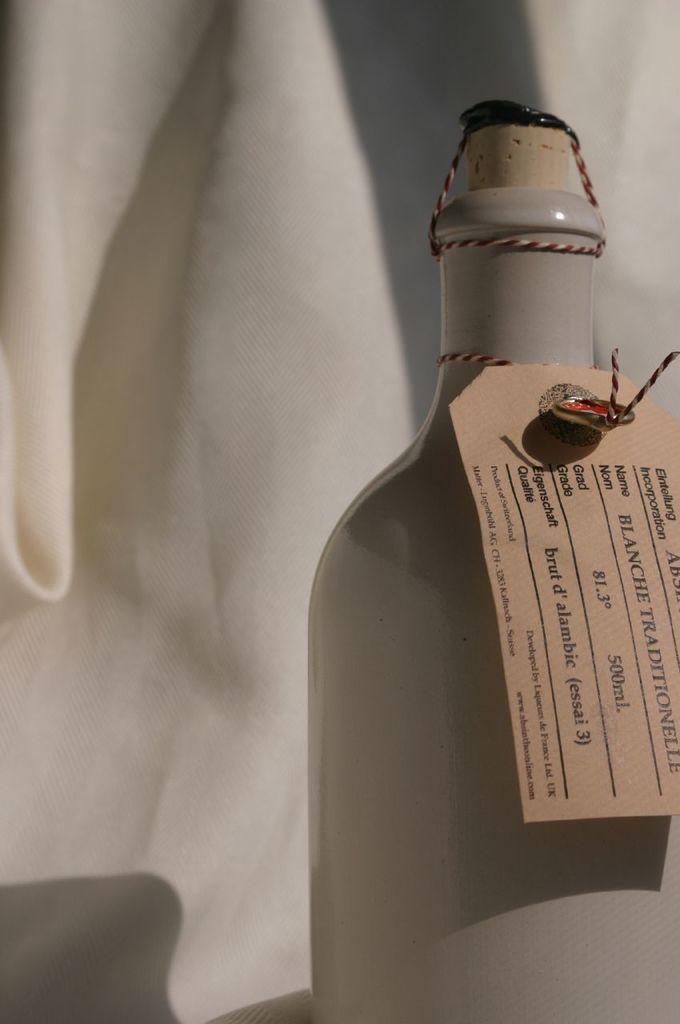How would you summarize this image in a sentence or two? In this picture we can see a bottle and a tag. There is a white background. 